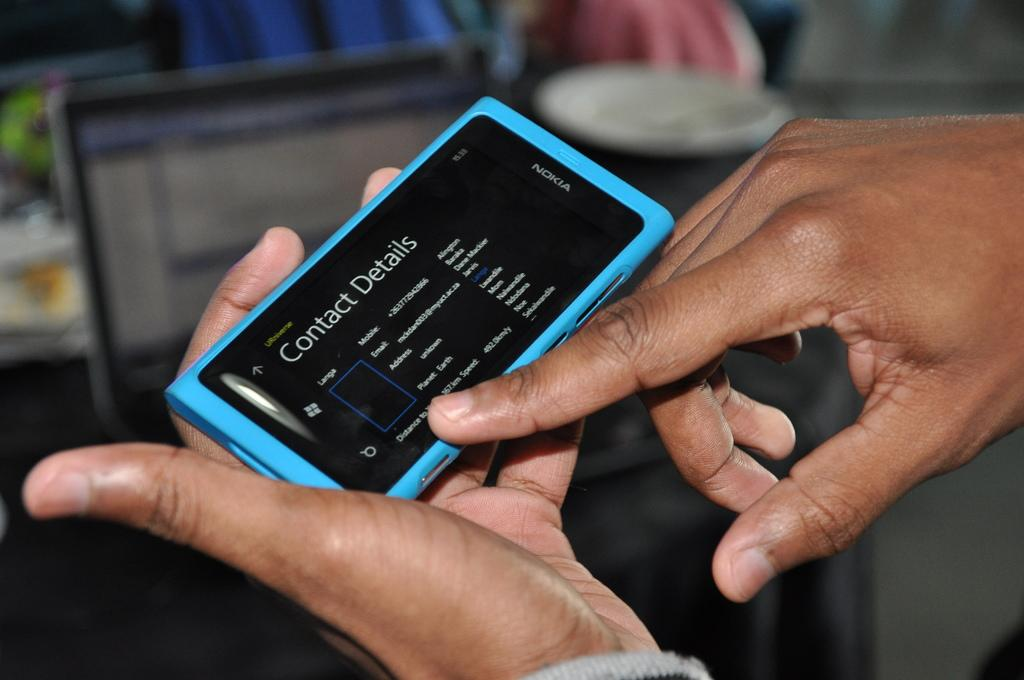What can be seen in the image that belongs to a person? There is a person's hand in the image. What is the hand holding? The hand is holding a mobile. Can you describe the background of the image? The background of the image is blurred. Can you see a toad attempting to climb the mobile in the image? There is no toad present in the image, and therefore no such activity can be observed. 